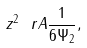Convert formula to latex. <formula><loc_0><loc_0><loc_500><loc_500>z ^ { 2 } \ r A \frac { 1 } { 6 \Psi _ { 2 } } ,</formula> 